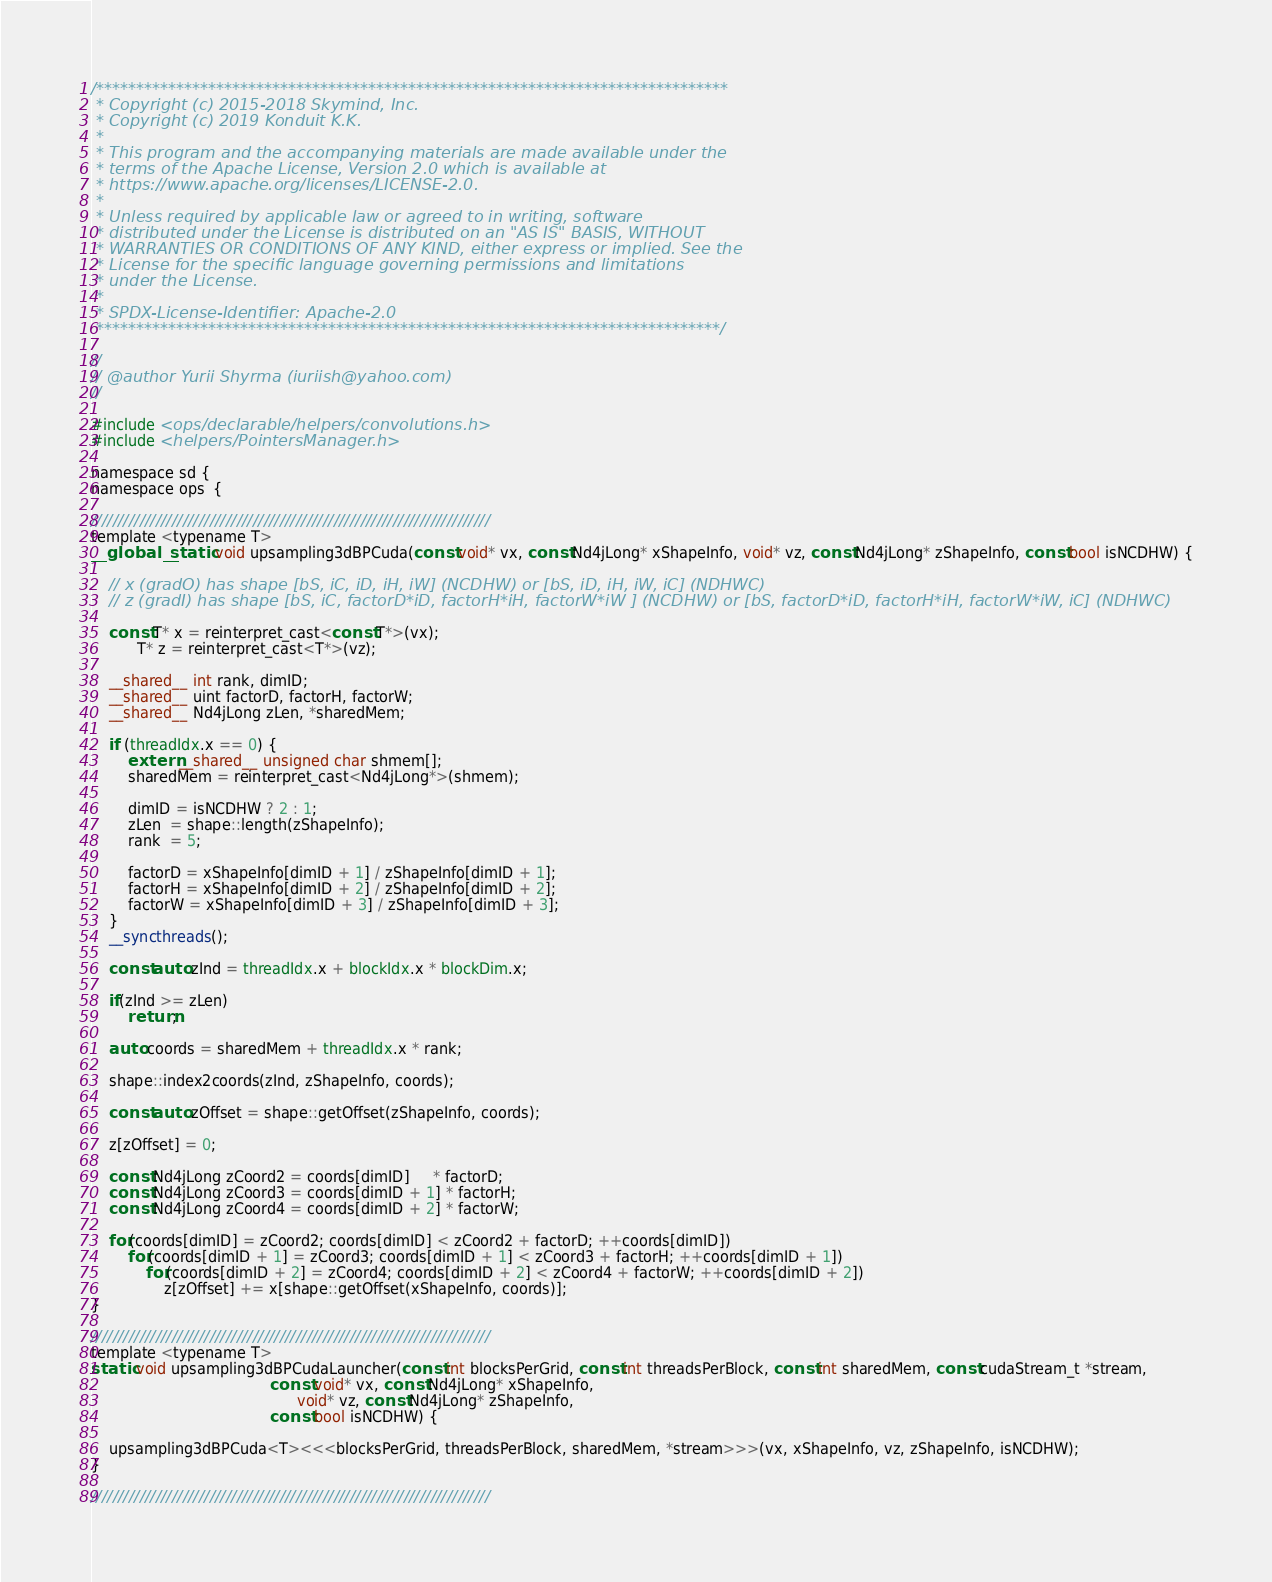Convert code to text. <code><loc_0><loc_0><loc_500><loc_500><_Cuda_>/*******************************************************************************
 * Copyright (c) 2015-2018 Skymind, Inc.
 * Copyright (c) 2019 Konduit K.K.
 *
 * This program and the accompanying materials are made available under the
 * terms of the Apache License, Version 2.0 which is available at
 * https://www.apache.org/licenses/LICENSE-2.0.
 *
 * Unless required by applicable law or agreed to in writing, software
 * distributed under the License is distributed on an "AS IS" BASIS, WITHOUT
 * WARRANTIES OR CONDITIONS OF ANY KIND, either express or implied. See the
 * License for the specific language governing permissions and limitations
 * under the License.
 *
 * SPDX-License-Identifier: Apache-2.0
 ******************************************************************************/

//
// @author Yurii Shyrma (iuriish@yahoo.com)
//

#include <ops/declarable/helpers/convolutions.h>
#include <helpers/PointersManager.h>

namespace sd {
namespace ops  {

//////////////////////////////////////////////////////////////////////////
template <typename T>
__global__ static void upsampling3dBPCuda(const void* vx, const Nd4jLong* xShapeInfo, void* vz, const Nd4jLong* zShapeInfo, const bool isNCDHW) {

    // x (gradO) has shape [bS, iC, iD, iH, iW] (NCDHW) or [bS, iD, iH, iW, iC] (NDHWC)
    // z (gradI) has shape [bS, iC, factorD*iD, factorH*iH, factorW*iW ] (NCDHW) or [bS, factorD*iD, factorH*iH, factorW*iW, iC] (NDHWC)

    const T* x = reinterpret_cast<const T*>(vx);
          T* z = reinterpret_cast<T*>(vz);

    __shared__ int rank, dimID;
    __shared__ uint factorD, factorH, factorW;
    __shared__ Nd4jLong zLen, *sharedMem;

    if (threadIdx.x == 0) {
        extern __shared__ unsigned char shmem[];
        sharedMem = reinterpret_cast<Nd4jLong*>(shmem);

        dimID = isNCDHW ? 2 : 1;
        zLen  = shape::length(zShapeInfo);
        rank  = 5;

        factorD = xShapeInfo[dimID + 1] / zShapeInfo[dimID + 1];
        factorH = xShapeInfo[dimID + 2] / zShapeInfo[dimID + 2];
        factorW = xShapeInfo[dimID + 3] / zShapeInfo[dimID + 3];
    }
    __syncthreads();

    const auto zInd = threadIdx.x + blockIdx.x * blockDim.x;

    if(zInd >= zLen)
        return;

    auto coords = sharedMem + threadIdx.x * rank;

    shape::index2coords(zInd, zShapeInfo, coords);

    const auto zOffset = shape::getOffset(zShapeInfo, coords);

    z[zOffset] = 0;

    const Nd4jLong zCoord2 = coords[dimID]     * factorD;
    const Nd4jLong zCoord3 = coords[dimID + 1] * factorH;
    const Nd4jLong zCoord4 = coords[dimID + 2] * factorW;

    for(coords[dimID] = zCoord2; coords[dimID] < zCoord2 + factorD; ++coords[dimID])
        for(coords[dimID + 1] = zCoord3; coords[dimID + 1] < zCoord3 + factorH; ++coords[dimID + 1])
            for(coords[dimID + 2] = zCoord4; coords[dimID + 2] < zCoord4 + factorW; ++coords[dimID + 2])
                z[zOffset] += x[shape::getOffset(xShapeInfo, coords)];
}

//////////////////////////////////////////////////////////////////////////
template <typename T>
static void upsampling3dBPCudaLauncher(const int blocksPerGrid, const int threadsPerBlock, const int sharedMem, const cudaStream_t *stream,
                                       const void* vx, const Nd4jLong* xShapeInfo,
                                             void* vz, const Nd4jLong* zShapeInfo,
                                       const bool isNCDHW) {

    upsampling3dBPCuda<T><<<blocksPerGrid, threadsPerBlock, sharedMem, *stream>>>(vx, xShapeInfo, vz, zShapeInfo, isNCDHW);
}

//////////////////////////////////////////////////////////////////////////</code> 